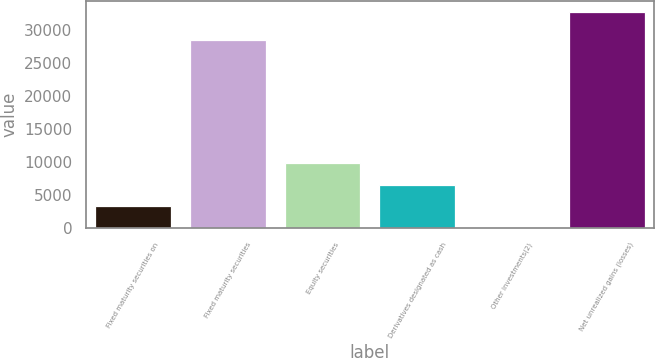Convert chart. <chart><loc_0><loc_0><loc_500><loc_500><bar_chart><fcel>Fixed maturity securities on<fcel>Fixed maturity securities<fcel>Equity securities<fcel>Derivatives designated as cash<fcel>Other investments(2)<fcel>Net unrealized gains (losses)<nl><fcel>3292.1<fcel>28526<fcel>9834.3<fcel>6563.2<fcel>21<fcel>32732<nl></chart> 